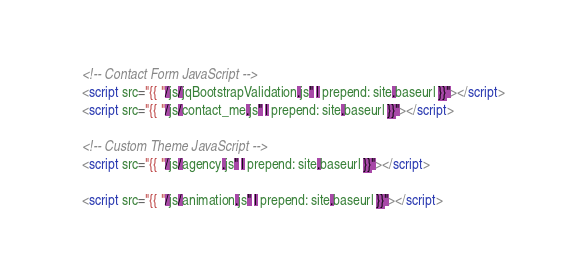Convert code to text. <code><loc_0><loc_0><loc_500><loc_500><_HTML_>    <!-- Contact Form JavaScript -->
    <script src="{{ "/js/jqBootstrapValidation.js" | prepend: site.baseurl }}"></script>
    <script src="{{ "/js/contact_me.js" | prepend: site.baseurl }}"></script>

    <!-- Custom Theme JavaScript -->
    <script src="{{ "/js/agency.js" | prepend: site.baseurl }}"></script>

    <script src="{{ "/js/animation.js" | prepend: site.baseurl }}"></script>
</code> 